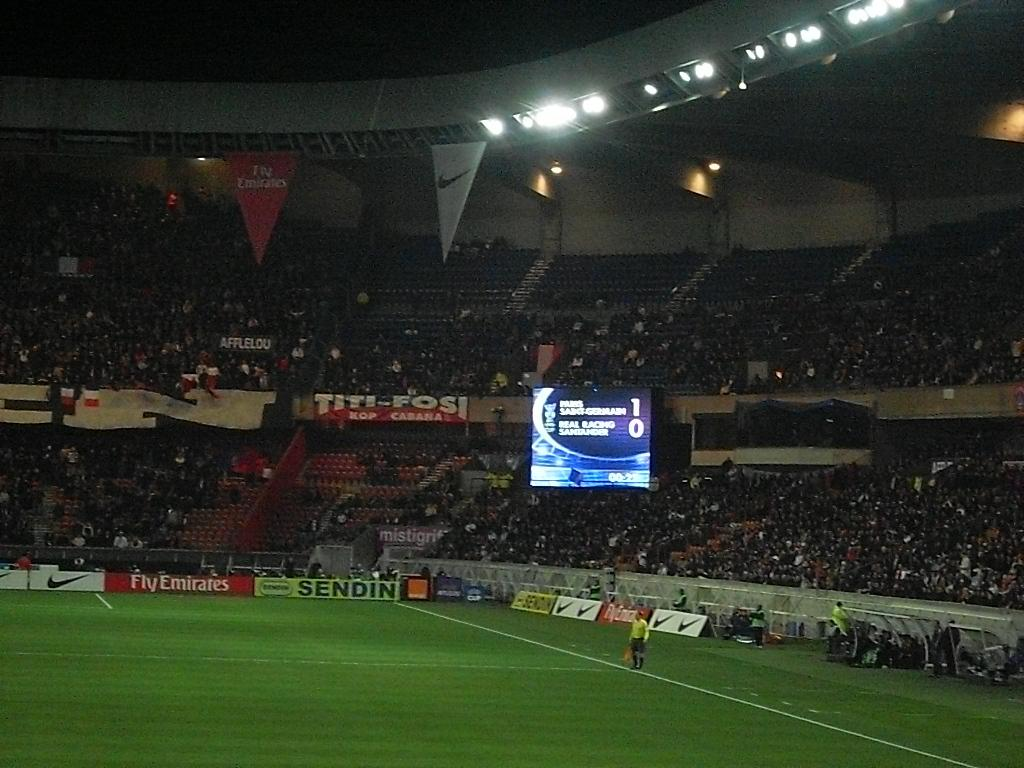Provide a one-sentence caption for the provided image. Emirate Airlines frequently acts as a sponsor in big soccer competition. 